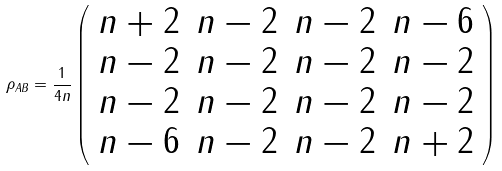Convert formula to latex. <formula><loc_0><loc_0><loc_500><loc_500>\rho _ { A B } = \frac { 1 } { 4 n } \left ( \begin{array} { c c c c } n + 2 & n - 2 & n - 2 & n - 6 \\ n - 2 & n - 2 & n - 2 & n - 2 \\ n - 2 & n - 2 & n - 2 & n - 2 \\ n - 6 & n - 2 & n - 2 & n + 2 \\ \end{array} \right )</formula> 